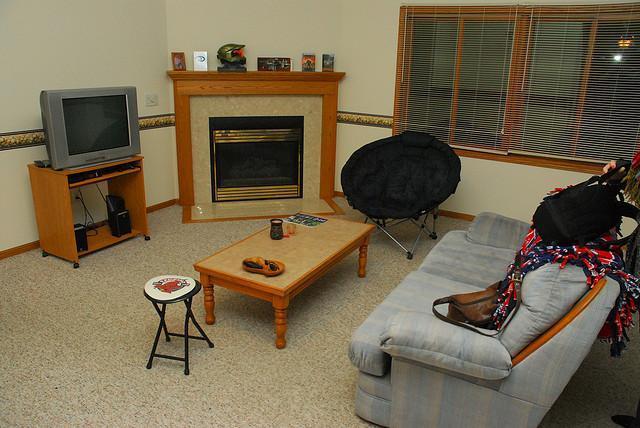How many backpacks are there?
Give a very brief answer. 1. How many bikes are there?
Give a very brief answer. 0. 